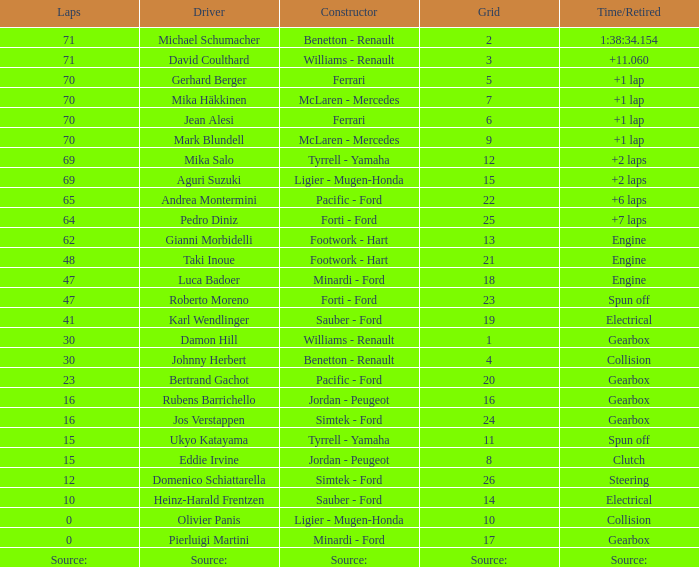Can you give me this table as a dict? {'header': ['Laps', 'Driver', 'Constructor', 'Grid', 'Time/Retired'], 'rows': [['71', 'Michael Schumacher', 'Benetton - Renault', '2', '1:38:34.154'], ['71', 'David Coulthard', 'Williams - Renault', '3', '+11.060'], ['70', 'Gerhard Berger', 'Ferrari', '5', '+1 lap'], ['70', 'Mika Häkkinen', 'McLaren - Mercedes', '7', '+1 lap'], ['70', 'Jean Alesi', 'Ferrari', '6', '+1 lap'], ['70', 'Mark Blundell', 'McLaren - Mercedes', '9', '+1 lap'], ['69', 'Mika Salo', 'Tyrrell - Yamaha', '12', '+2 laps'], ['69', 'Aguri Suzuki', 'Ligier - Mugen-Honda', '15', '+2 laps'], ['65', 'Andrea Montermini', 'Pacific - Ford', '22', '+6 laps'], ['64', 'Pedro Diniz', 'Forti - Ford', '25', '+7 laps'], ['62', 'Gianni Morbidelli', 'Footwork - Hart', '13', 'Engine'], ['48', 'Taki Inoue', 'Footwork - Hart', '21', 'Engine'], ['47', 'Luca Badoer', 'Minardi - Ford', '18', 'Engine'], ['47', 'Roberto Moreno', 'Forti - Ford', '23', 'Spun off'], ['41', 'Karl Wendlinger', 'Sauber - Ford', '19', 'Electrical'], ['30', 'Damon Hill', 'Williams - Renault', '1', 'Gearbox'], ['30', 'Johnny Herbert', 'Benetton - Renault', '4', 'Collision'], ['23', 'Bertrand Gachot', 'Pacific - Ford', '20', 'Gearbox'], ['16', 'Rubens Barrichello', 'Jordan - Peugeot', '16', 'Gearbox'], ['16', 'Jos Verstappen', 'Simtek - Ford', '24', 'Gearbox'], ['15', 'Ukyo Katayama', 'Tyrrell - Yamaha', '11', 'Spun off'], ['15', 'Eddie Irvine', 'Jordan - Peugeot', '8', 'Clutch'], ['12', 'Domenico Schiattarella', 'Simtek - Ford', '26', 'Steering'], ['10', 'Heinz-Harald Frentzen', 'Sauber - Ford', '14', 'Electrical'], ['0', 'Olivier Panis', 'Ligier - Mugen-Honda', '10', 'Collision'], ['0', 'Pierluigi Martini', 'Minardi - Ford', '17', 'Gearbox'], ['Source:', 'Source:', 'Source:', 'Source:', 'Source:']]} How many laps were there in grid 21? 48.0. 